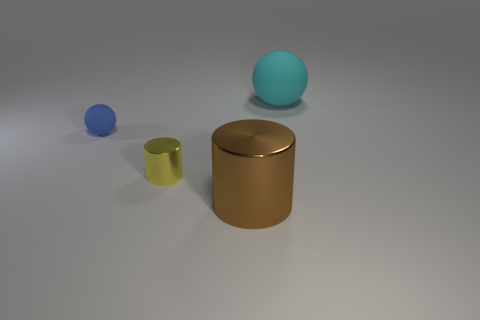There is a blue thing that is the same size as the yellow object; what is its shape?
Ensure brevity in your answer.  Sphere. What number of things are both behind the big cylinder and to the left of the cyan matte sphere?
Provide a succinct answer. 2. Are there fewer blue spheres that are behind the tiny blue sphere than cyan matte cylinders?
Provide a short and direct response. No. Is there another brown object that has the same size as the brown thing?
Your response must be concise. No. What is the color of the object that is the same material as the tiny cylinder?
Your answer should be compact. Brown. What number of large cyan matte balls are behind the metal cylinder that is in front of the tiny yellow thing?
Your answer should be very brief. 1. What is the object that is right of the tiny cylinder and in front of the blue matte ball made of?
Keep it short and to the point. Metal. Does the small object in front of the tiny rubber sphere have the same shape as the brown object?
Your response must be concise. Yes. Are there fewer small purple metallic cylinders than cyan matte balls?
Ensure brevity in your answer.  Yes. What number of spheres have the same color as the big metallic cylinder?
Offer a very short reply. 0. 